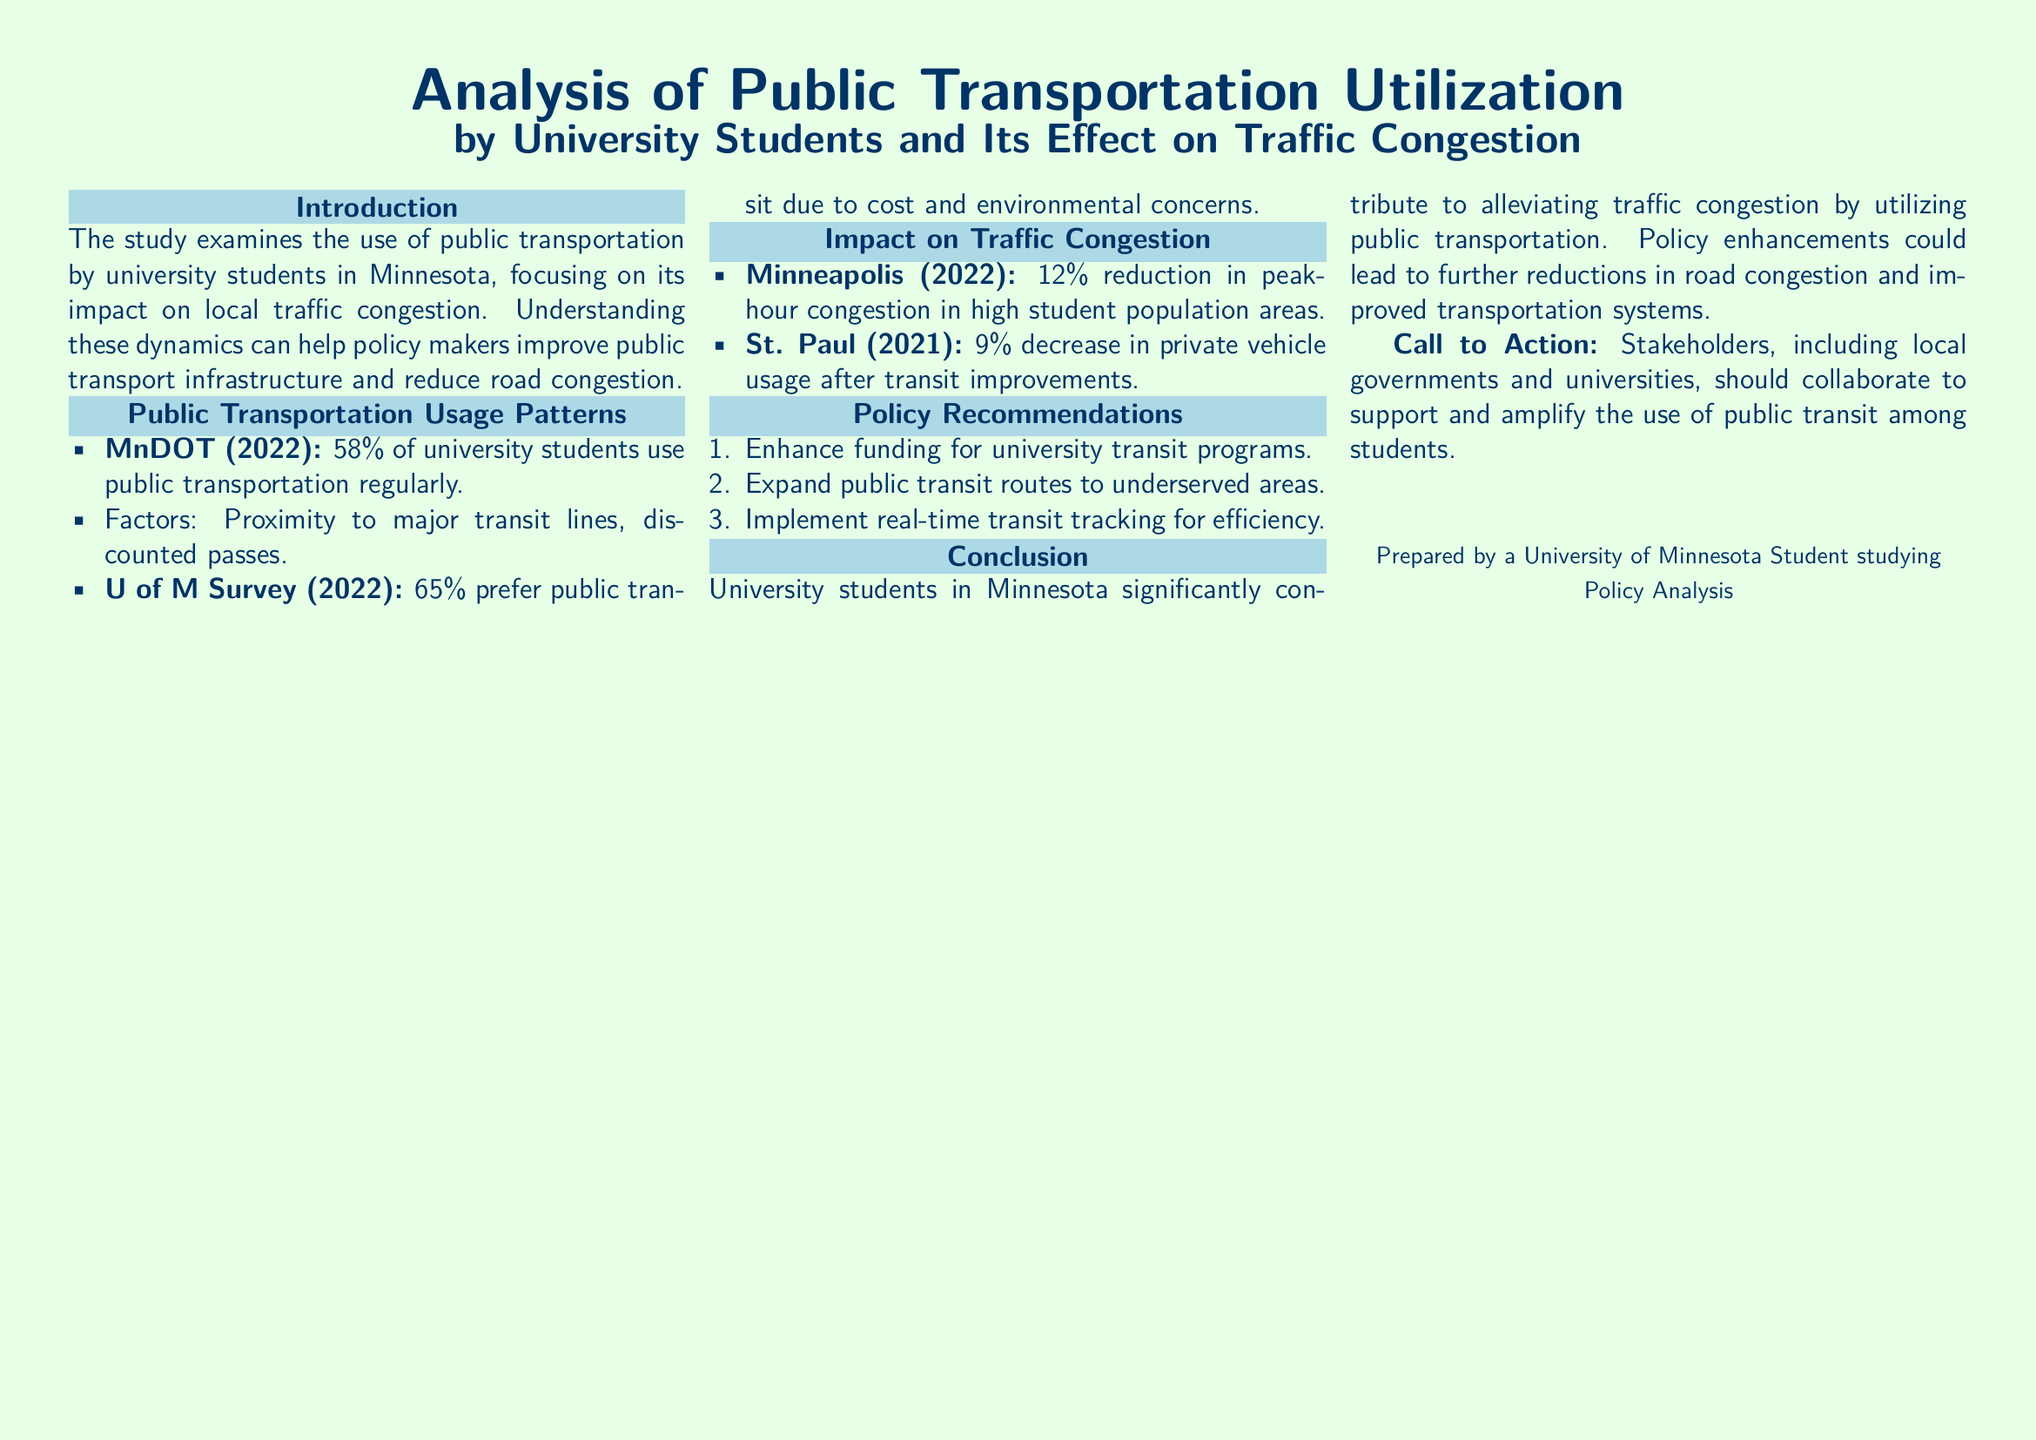What percentage of university students use public transportation regularly? The document states that 58% of university students use public transportation regularly according to MnDOT (2022).
Answer: 58% What is the main reason for student preference for public transit according to the U of M Survey (2022)? The survey indicates that 65% of university students prefer public transit due to cost and environmental concerns.
Answer: Cost and environmental concerns What has been the percentage reduction in peak-hour congestion in high student population areas in Minneapolis (2022)? The document reports a 12% reduction in peak-hour congestion in high student population areas in Minneapolis.
Answer: 12% What policy recommendation involves tracking for efficiency? The document mentions implementing real-time transit tracking as a policy recommendation for improving efficiency.
Answer: Real-time transit tracking What was the decrease in private vehicle usage in St. Paul (2021) after transit improvements? The document states there was a 9% decrease in private vehicle usage in St. Paul after transit improvements.
Answer: 9% What should stakeholders do to enhance public transit utilization among students? The document calls for stakeholders to collaborate to support and amplify the use of public transit among students.
Answer: Collaborate to support and amplify What does the introduction mention as a goal of the study? The introduction indicates that the study aims to help policymakers improve public transport infrastructure and reduce road congestion.
Answer: Improve public transport infrastructure and reduce road congestion How did public transportation utilization by university students impact traffic congestion? The conclusion highlights that university students significantly contribute to alleviating traffic congestion by utilizing public transportation.
Answer: Alleviating traffic congestion 